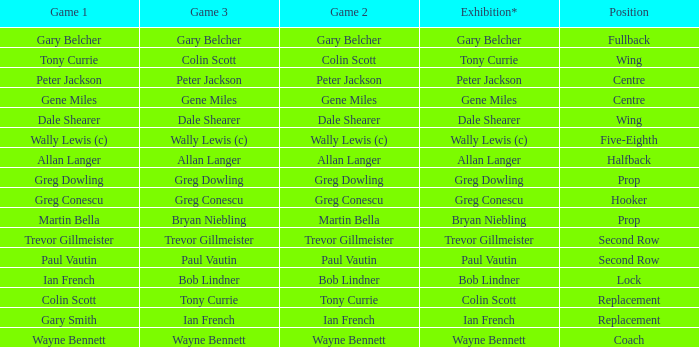What exhibition has greg conescu as game 1? Greg Conescu. 